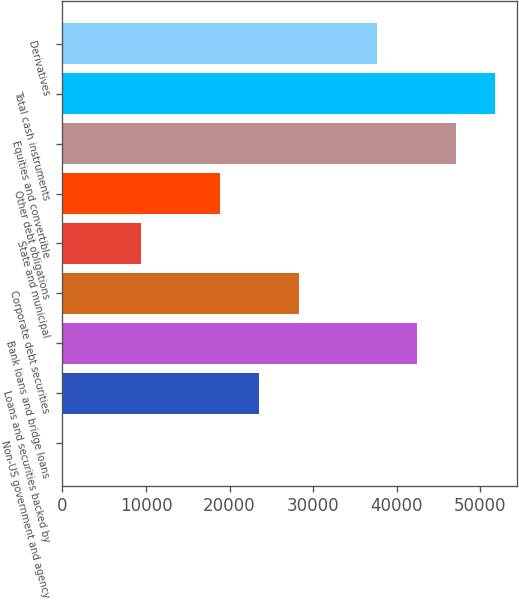Convert chart to OTSL. <chart><loc_0><loc_0><loc_500><loc_500><bar_chart><fcel>Non-US government and agency<fcel>Loans and securities backed by<fcel>Bank loans and bridge loans<fcel>Corporate debt securities<fcel>State and municipal<fcel>Other debt obligations<fcel>Equities and convertible<fcel>Total cash instruments<fcel>Derivatives<nl><fcel>26<fcel>23560.5<fcel>42388.1<fcel>28267.4<fcel>9439.8<fcel>18853.6<fcel>47095<fcel>51801.9<fcel>37681.2<nl></chart> 